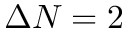<formula> <loc_0><loc_0><loc_500><loc_500>\Delta N = 2</formula> 